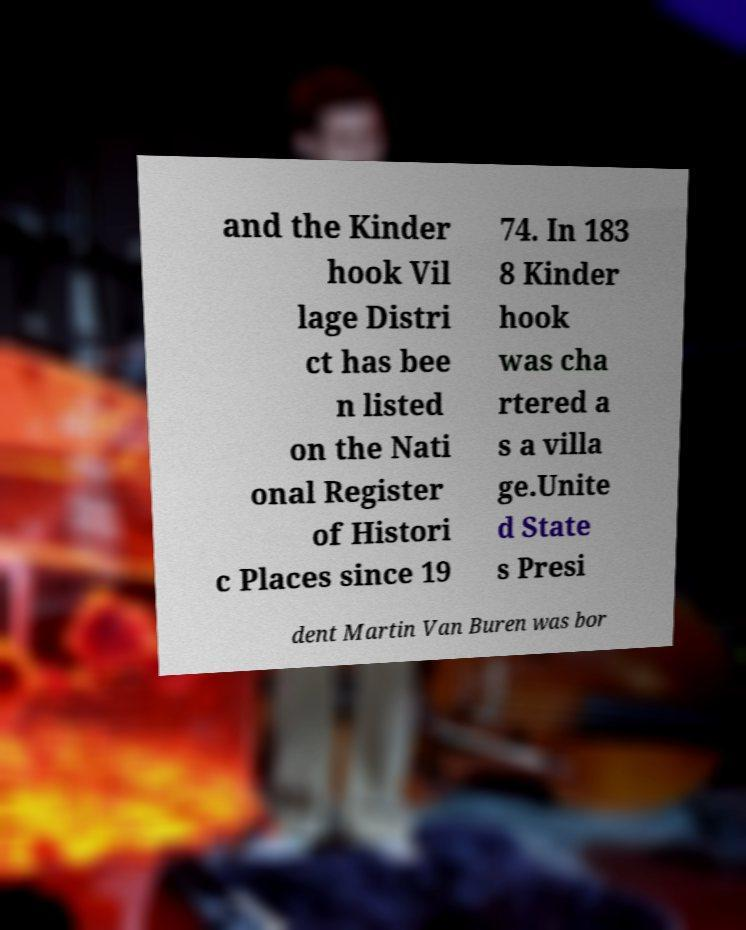Could you extract and type out the text from this image? and the Kinder hook Vil lage Distri ct has bee n listed on the Nati onal Register of Histori c Places since 19 74. In 183 8 Kinder hook was cha rtered a s a villa ge.Unite d State s Presi dent Martin Van Buren was bor 